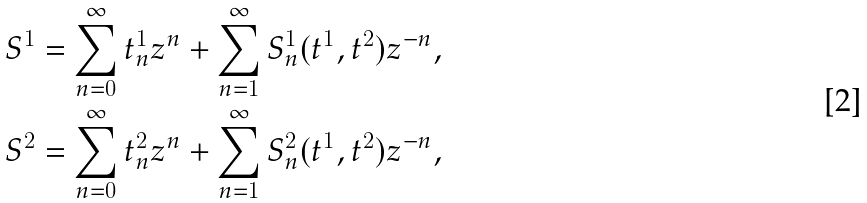<formula> <loc_0><loc_0><loc_500><loc_500>S ^ { 1 } = \sum _ { n = 0 } ^ { \infty } t ^ { 1 } _ { n } z ^ { n } + \sum _ { n = 1 } ^ { \infty } S ^ { 1 } _ { n } ( t ^ { 1 } , t ^ { 2 } ) z ^ { - n } , \\ S ^ { 2 } = \sum _ { n = 0 } ^ { \infty } t ^ { 2 } _ { n } z ^ { n } + \sum _ { n = 1 } ^ { \infty } S ^ { 2 } _ { n } ( t ^ { 1 } , t ^ { 2 } ) z ^ { - n } ,</formula> 